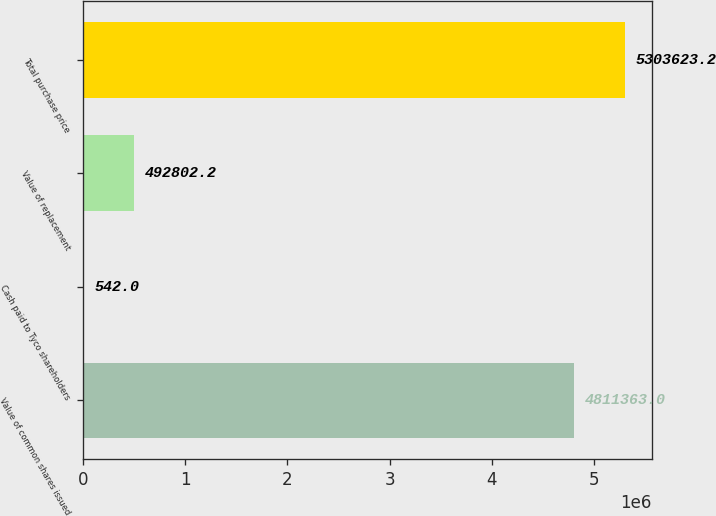Convert chart. <chart><loc_0><loc_0><loc_500><loc_500><bar_chart><fcel>Value of common shares issued<fcel>Cash paid to Tyco shareholders<fcel>Value of replacement<fcel>Total purchase price<nl><fcel>4.81136e+06<fcel>542<fcel>492802<fcel>5.30362e+06<nl></chart> 